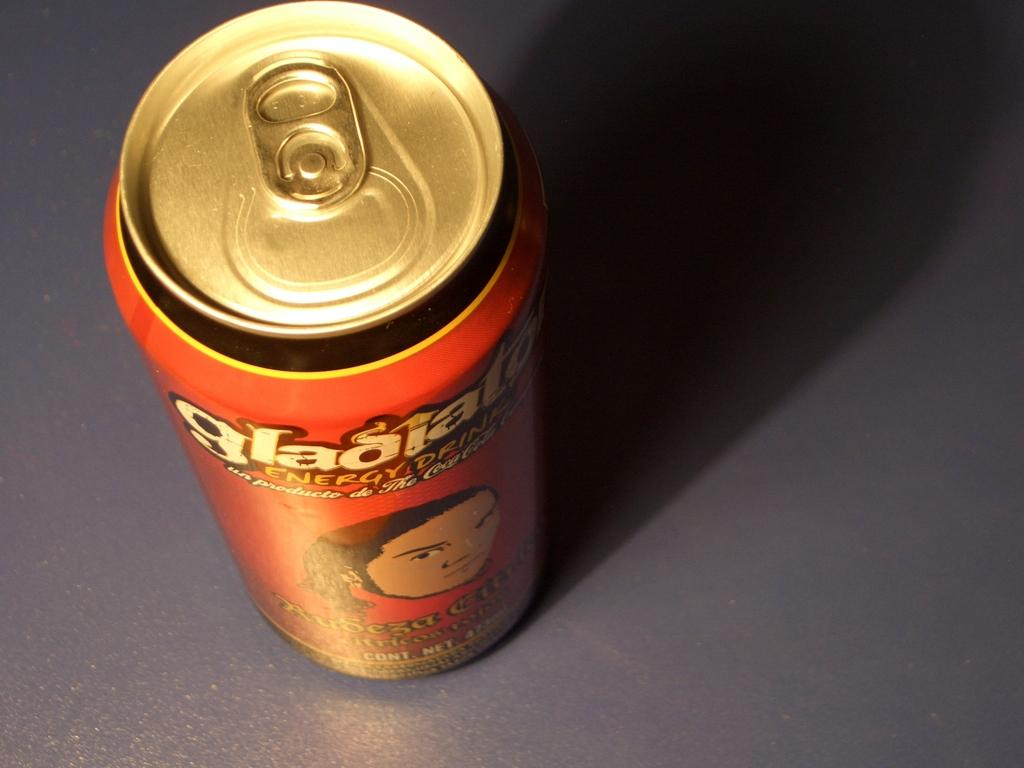<image>
Render a clear and concise summary of the photo. A can of some sort of beverage called Gladiator. 